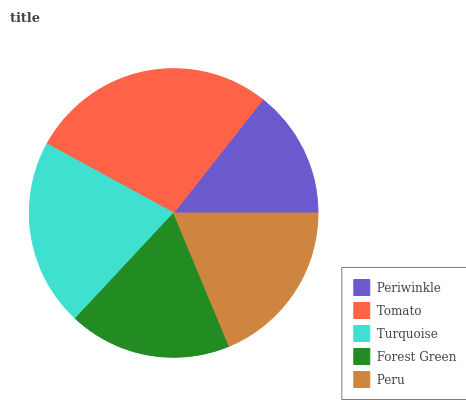Is Periwinkle the minimum?
Answer yes or no. Yes. Is Tomato the maximum?
Answer yes or no. Yes. Is Turquoise the minimum?
Answer yes or no. No. Is Turquoise the maximum?
Answer yes or no. No. Is Tomato greater than Turquoise?
Answer yes or no. Yes. Is Turquoise less than Tomato?
Answer yes or no. Yes. Is Turquoise greater than Tomato?
Answer yes or no. No. Is Tomato less than Turquoise?
Answer yes or no. No. Is Peru the high median?
Answer yes or no. Yes. Is Peru the low median?
Answer yes or no. Yes. Is Turquoise the high median?
Answer yes or no. No. Is Tomato the low median?
Answer yes or no. No. 